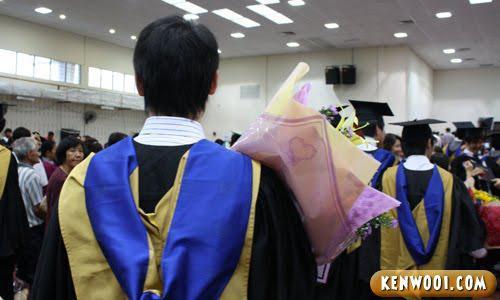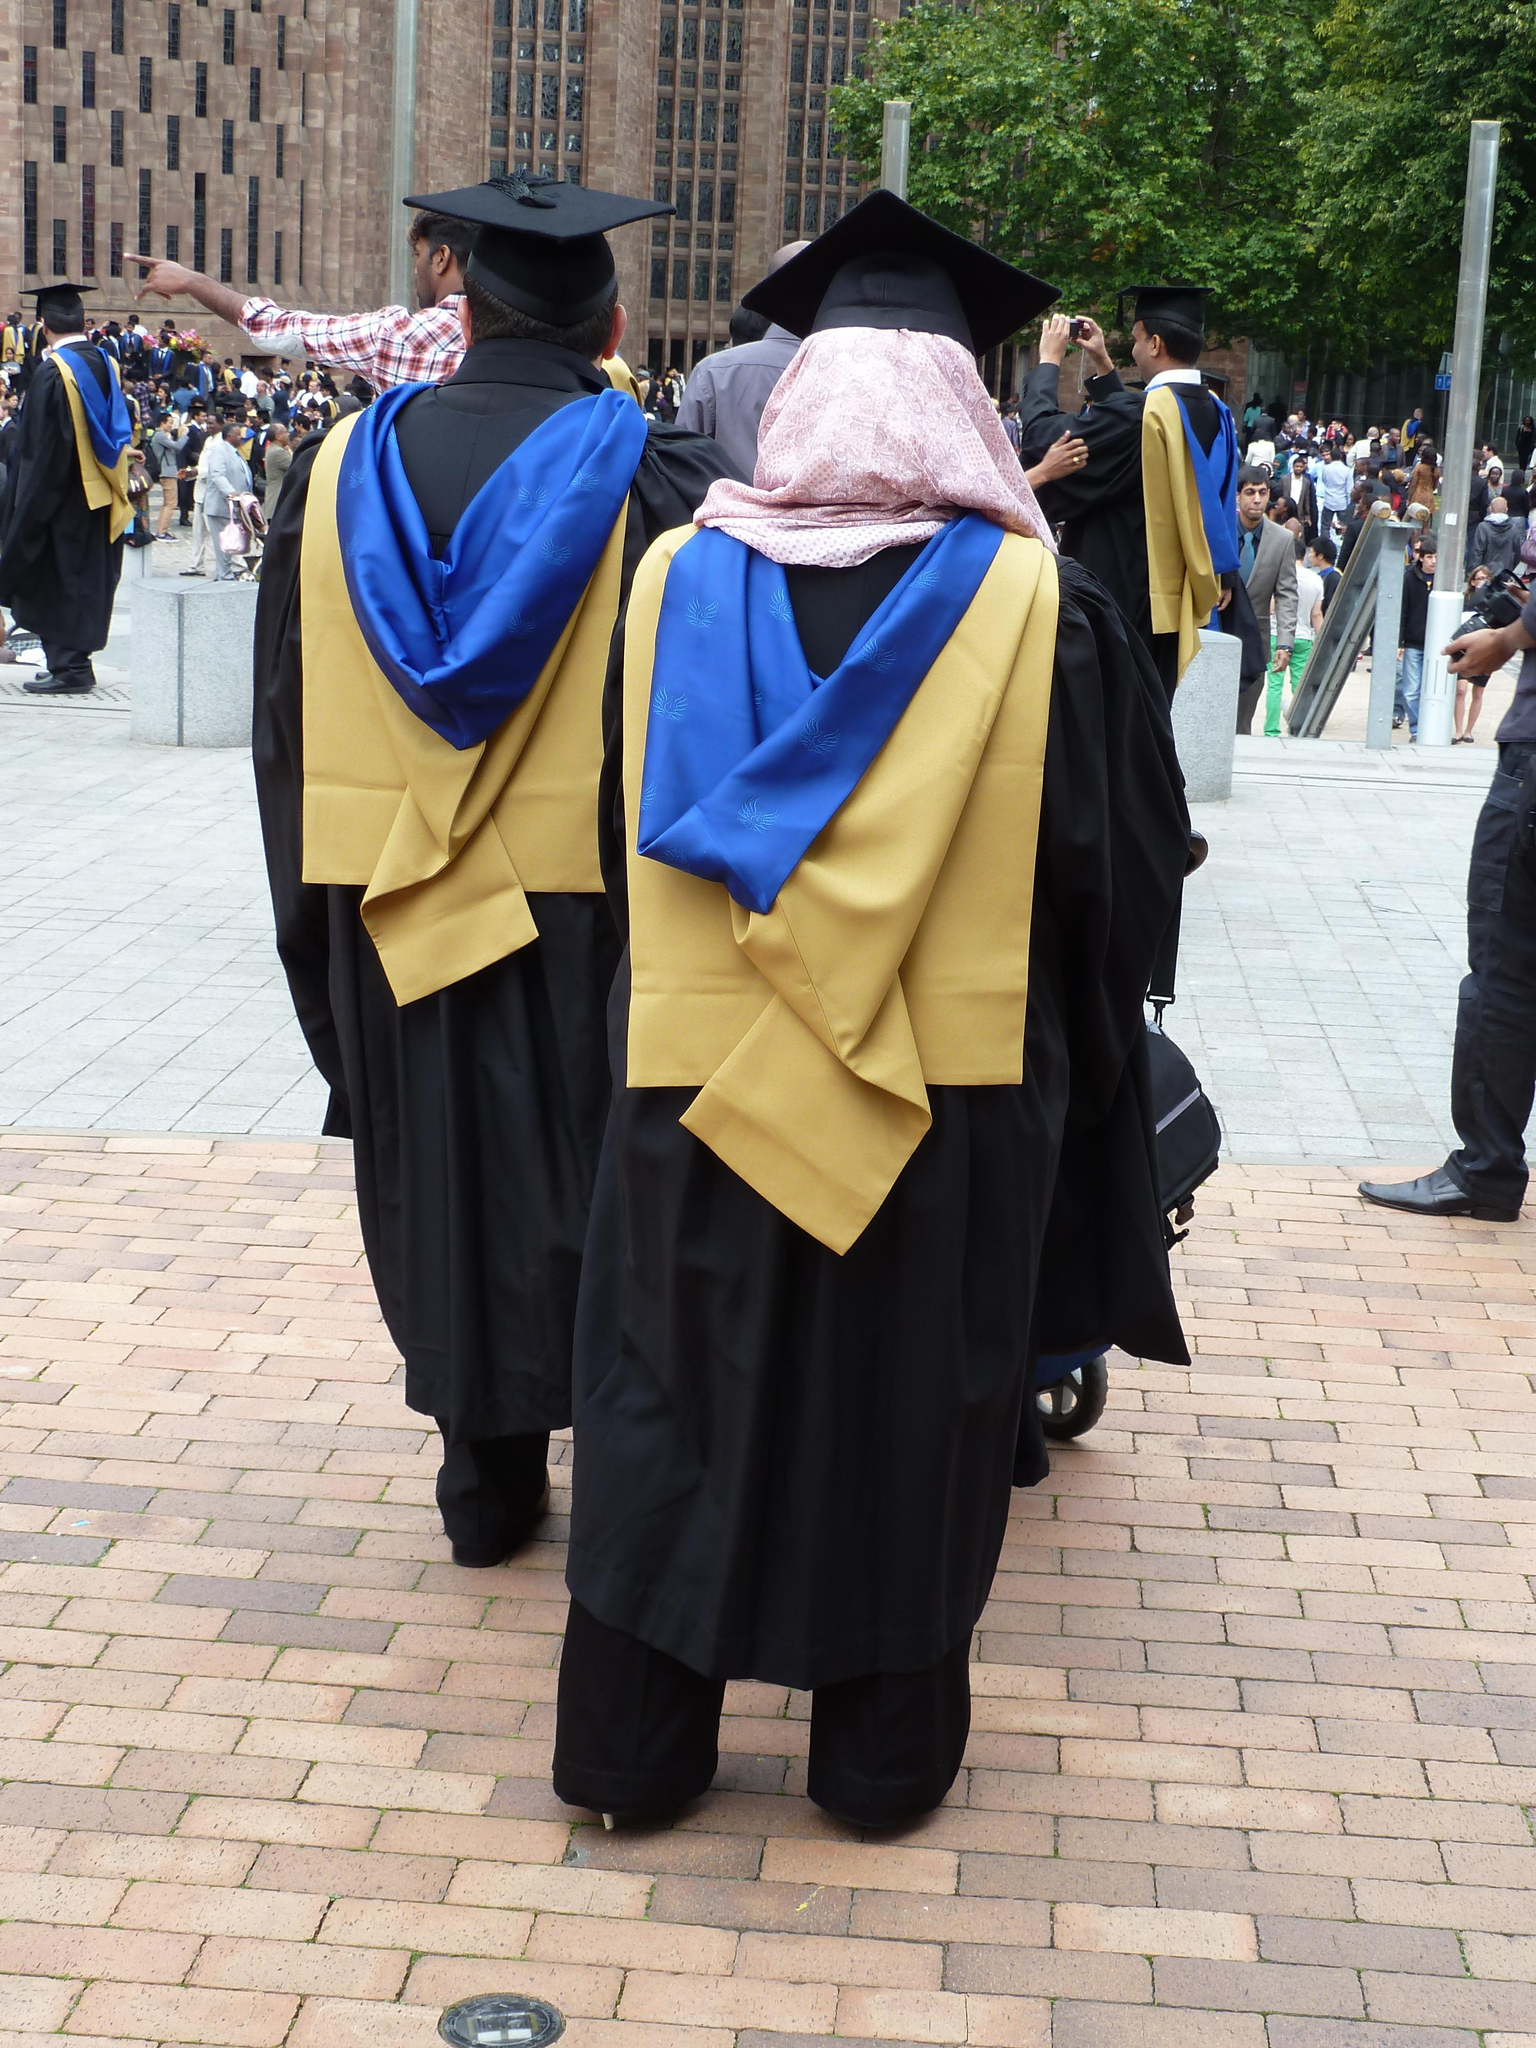The first image is the image on the left, the second image is the image on the right. For the images shown, is this caption "An image features a forward-facing female in a black gown and black graduation cap." true? Answer yes or no. No. 